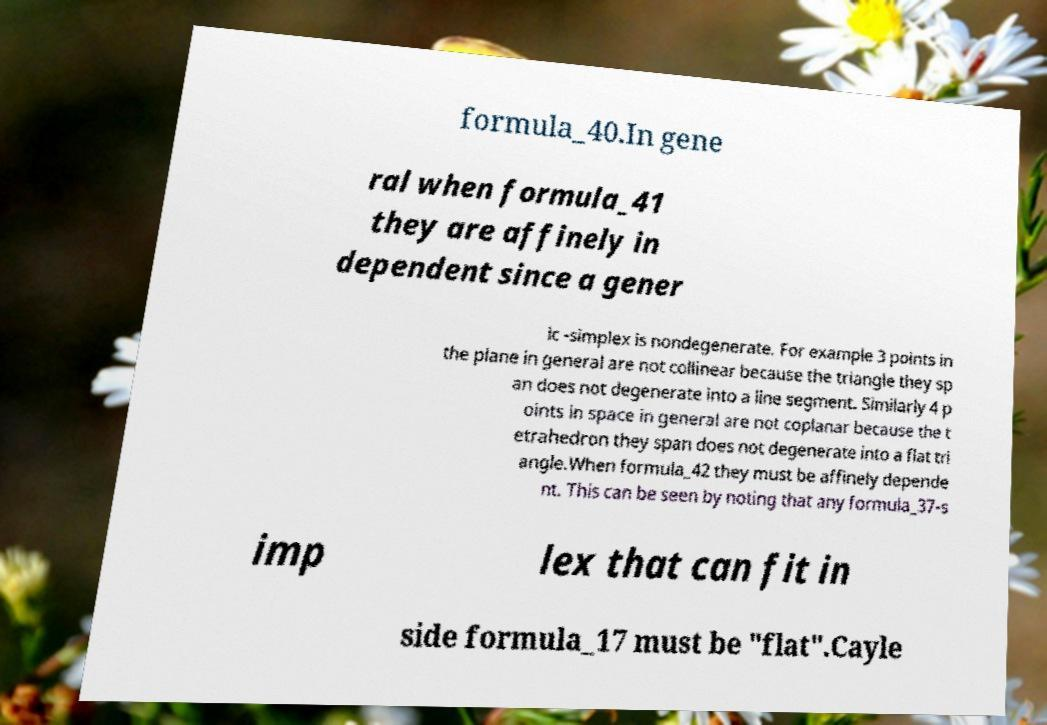Could you assist in decoding the text presented in this image and type it out clearly? formula_40.In gene ral when formula_41 they are affinely in dependent since a gener ic -simplex is nondegenerate. For example 3 points in the plane in general are not collinear because the triangle they sp an does not degenerate into a line segment. Similarly 4 p oints in space in general are not coplanar because the t etrahedron they span does not degenerate into a flat tri angle.When formula_42 they must be affinely depende nt. This can be seen by noting that any formula_37-s imp lex that can fit in side formula_17 must be "flat".Cayle 